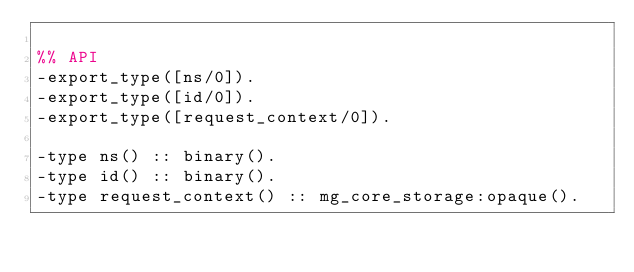<code> <loc_0><loc_0><loc_500><loc_500><_Erlang_>
%% API
-export_type([ns/0]).
-export_type([id/0]).
-export_type([request_context/0]).

-type ns() :: binary().
-type id() :: binary().
-type request_context() :: mg_core_storage:opaque().
</code> 